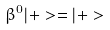<formula> <loc_0><loc_0><loc_500><loc_500>\beta ^ { 0 } | + > = | + ></formula> 